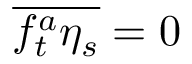Convert formula to latex. <formula><loc_0><loc_0><loc_500><loc_500>\overline { { f _ { t } ^ { a } \eta _ { s } } } = 0</formula> 